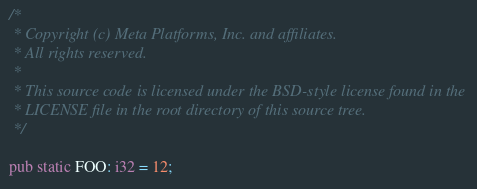<code> <loc_0><loc_0><loc_500><loc_500><_Rust_>/*
 * Copyright (c) Meta Platforms, Inc. and affiliates.
 * All rights reserved.
 *
 * This source code is licensed under the BSD-style license found in the
 * LICENSE file in the root directory of this source tree.
 */

pub static FOO: i32 = 12;
</code> 